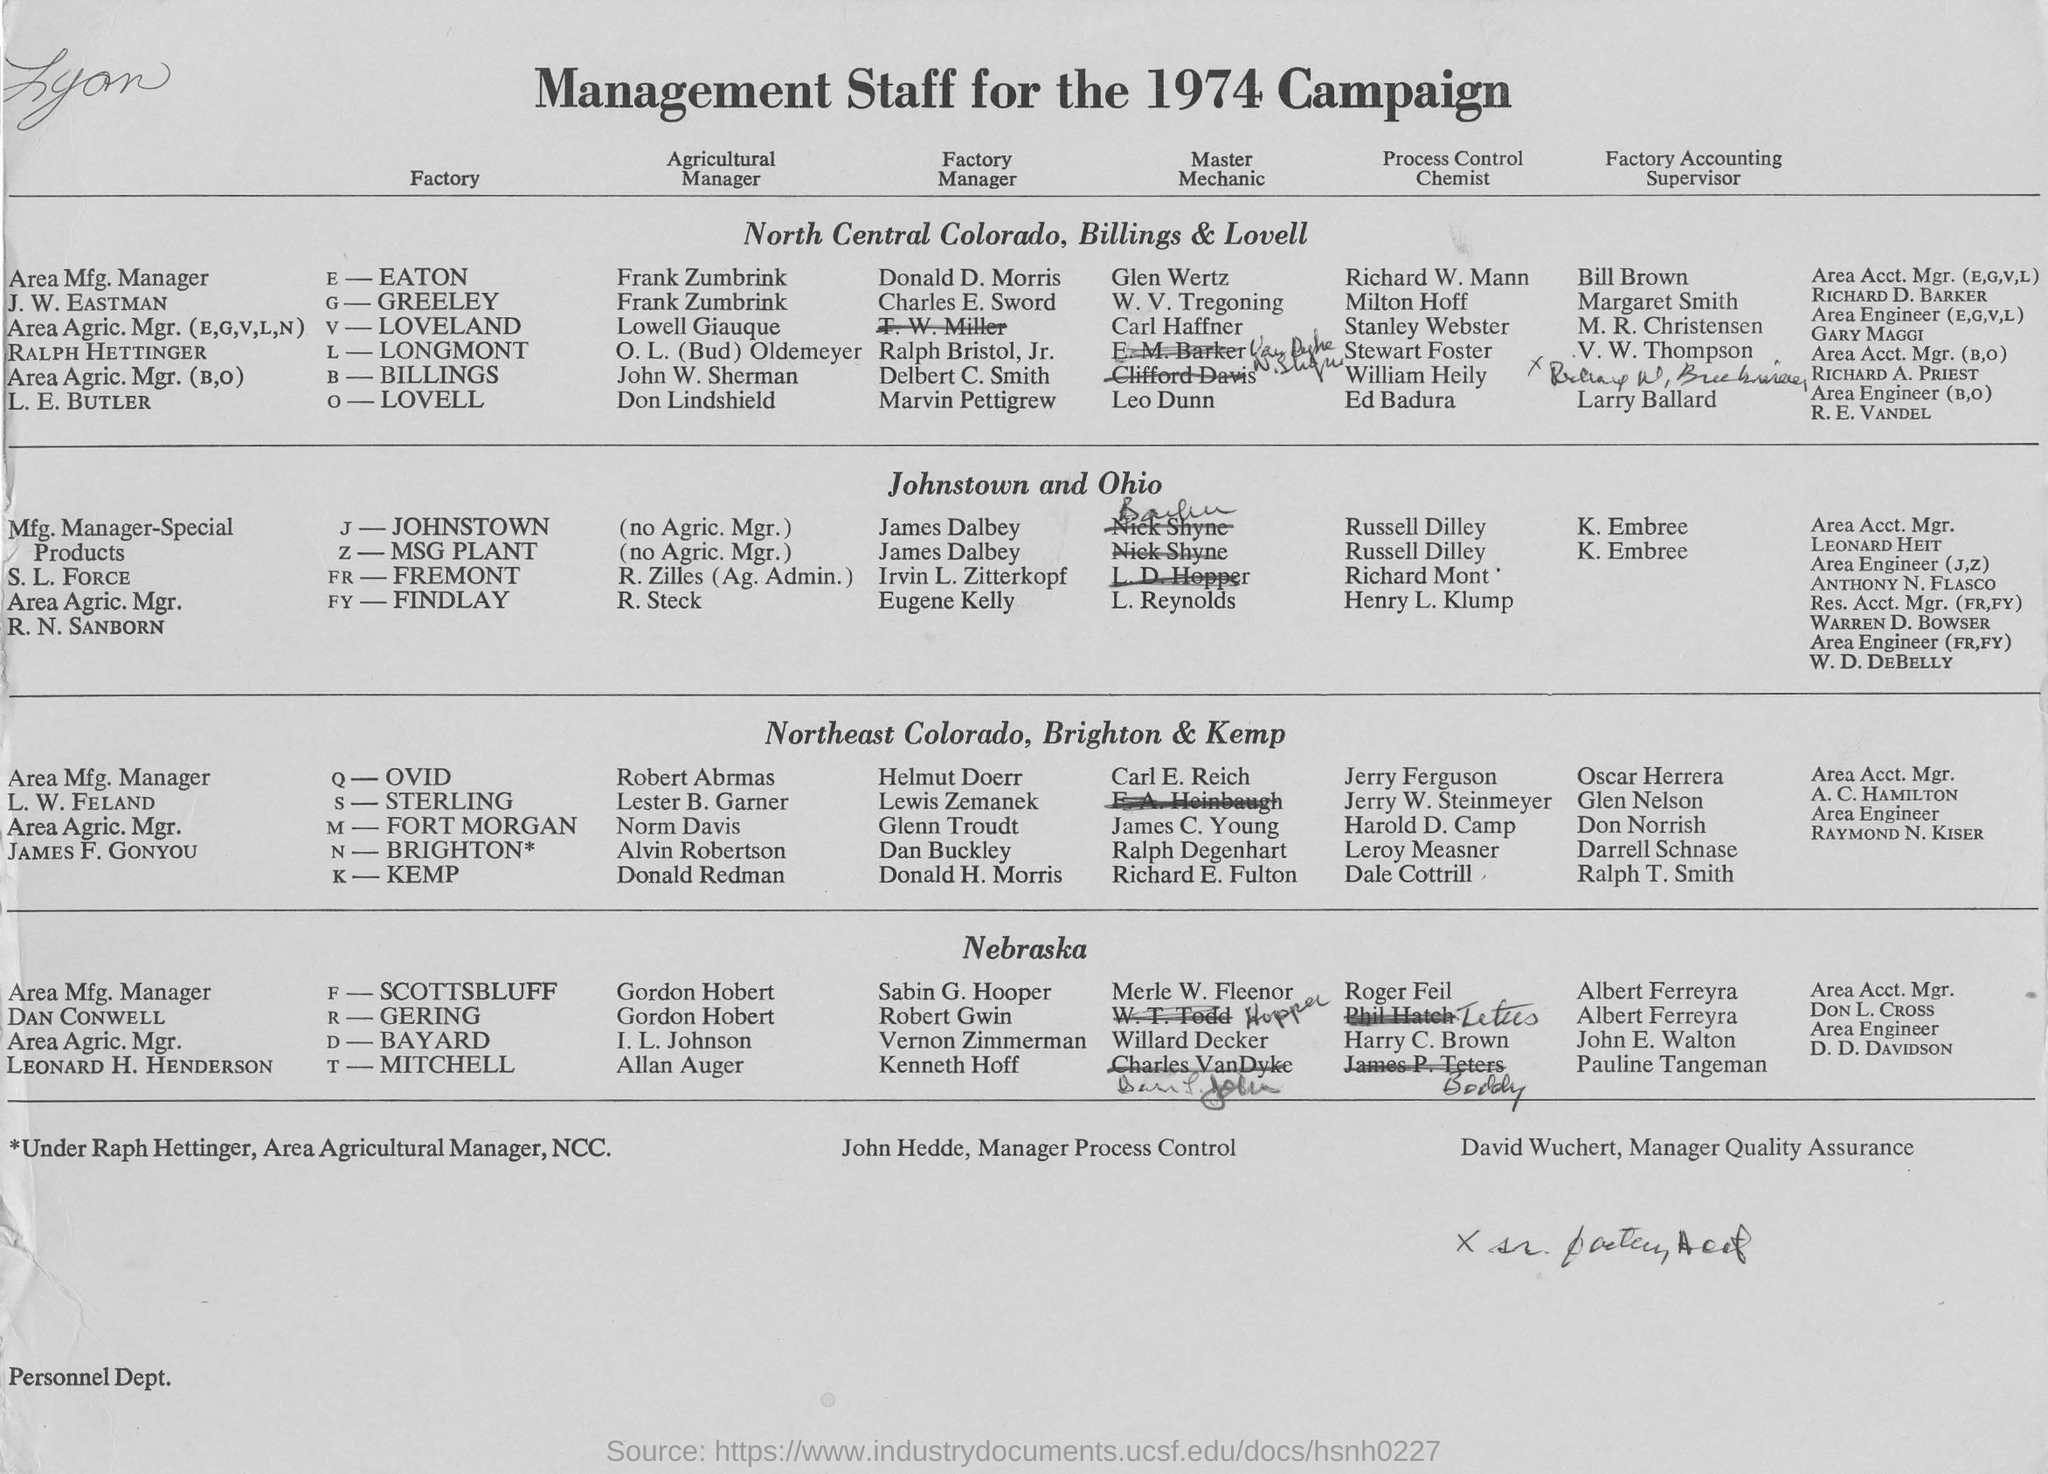What is the Title of the Document ?
Offer a terse response. Management Staff for the 1974 Campaign. Who is the Manager of Process control ?
Give a very brief answer. John Hedde,. Who is the Manager of Quality Assurance ?
Keep it short and to the point. David Wuchert,. 